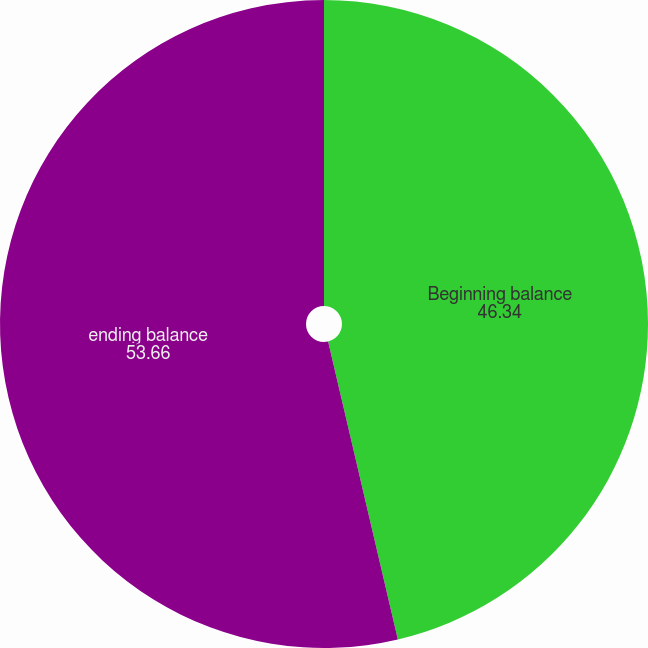Convert chart. <chart><loc_0><loc_0><loc_500><loc_500><pie_chart><fcel>Beginning balance<fcel>ending balance<nl><fcel>46.34%<fcel>53.66%<nl></chart> 